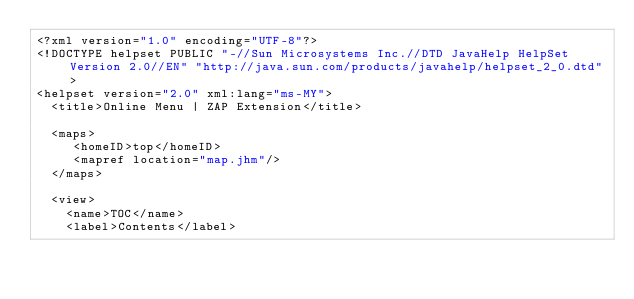Convert code to text. <code><loc_0><loc_0><loc_500><loc_500><_Haskell_><?xml version="1.0" encoding="UTF-8"?>
<!DOCTYPE helpset PUBLIC "-//Sun Microsystems Inc.//DTD JavaHelp HelpSet Version 2.0//EN" "http://java.sun.com/products/javahelp/helpset_2_0.dtd">
<helpset version="2.0" xml:lang="ms-MY">
  <title>Online Menu | ZAP Extension</title>

  <maps>
     <homeID>top</homeID>
     <mapref location="map.jhm"/>
  </maps>

  <view>
    <name>TOC</name>
    <label>Contents</label></code> 